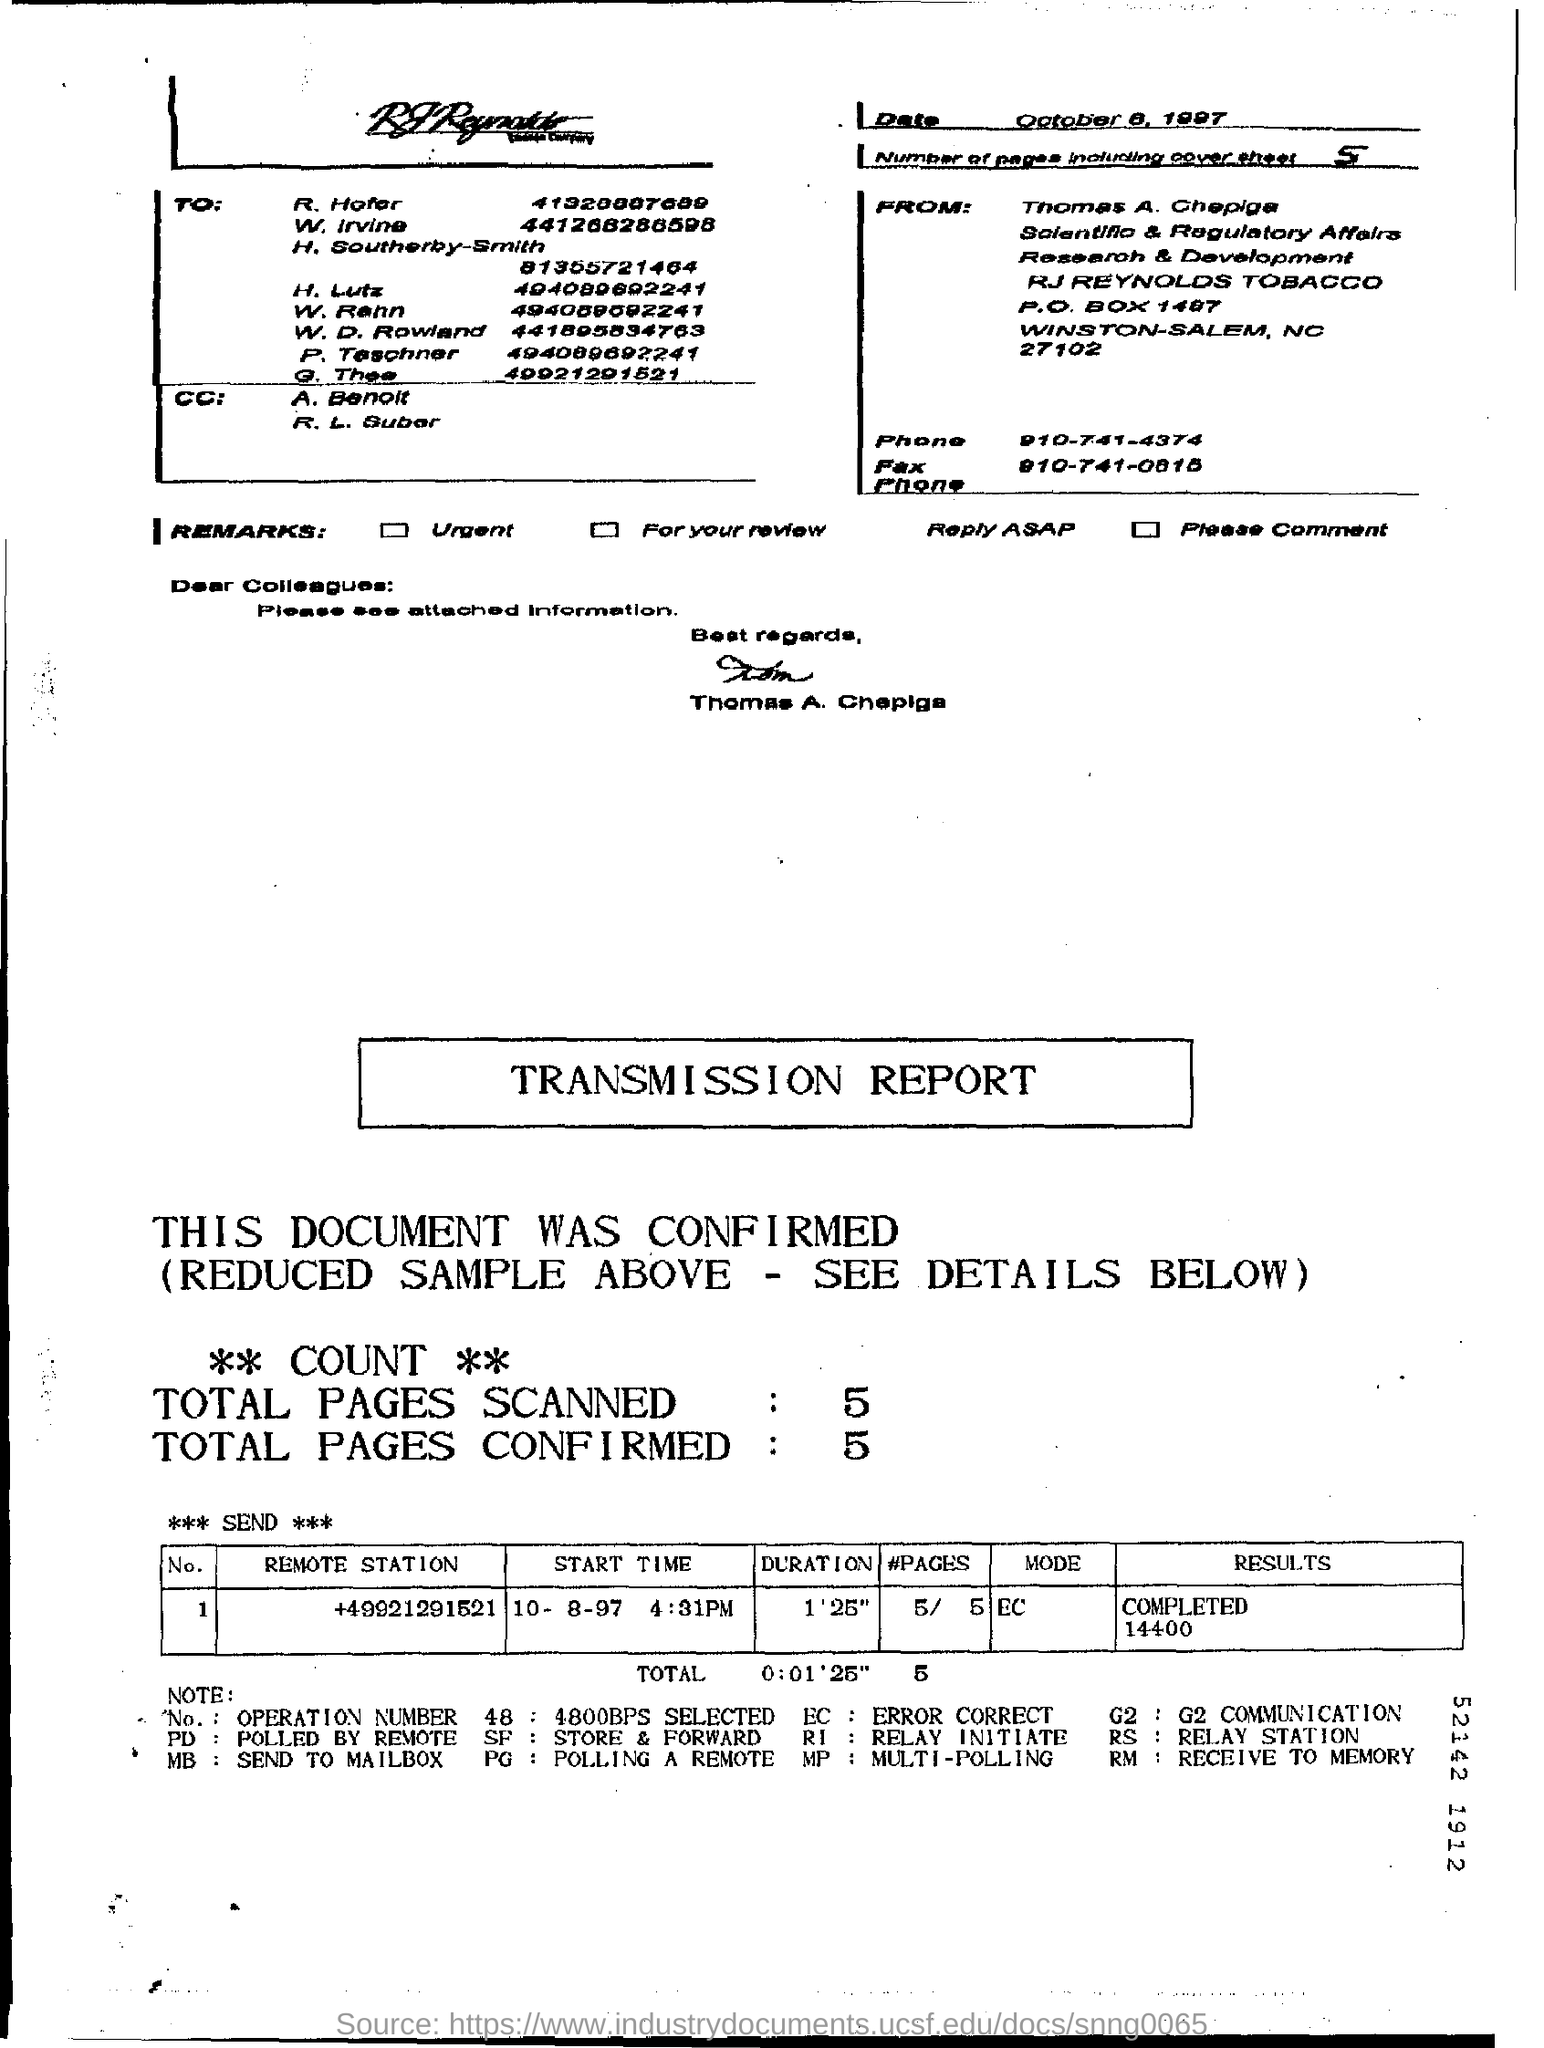What is the count of total pages scanned?
Give a very brief answer. 5. What is the count of total pages confirmed
Give a very brief answer. 5. What does PD refer to?
Your response must be concise. Polled by remote. What is the total number of pages including cover pages?
Your answer should be very brief. 5. 